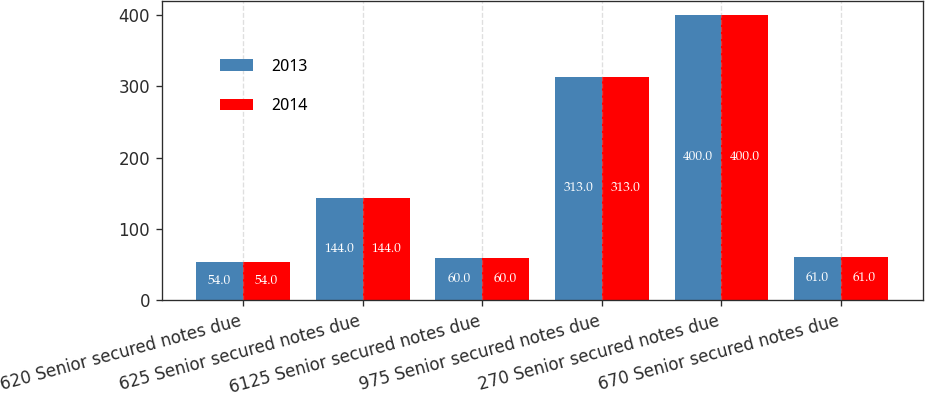<chart> <loc_0><loc_0><loc_500><loc_500><stacked_bar_chart><ecel><fcel>620 Senior secured notes due<fcel>625 Senior secured notes due<fcel>6125 Senior secured notes due<fcel>975 Senior secured notes due<fcel>270 Senior secured notes due<fcel>670 Senior secured notes due<nl><fcel>2013<fcel>54<fcel>144<fcel>60<fcel>313<fcel>400<fcel>61<nl><fcel>2014<fcel>54<fcel>144<fcel>60<fcel>313<fcel>400<fcel>61<nl></chart> 